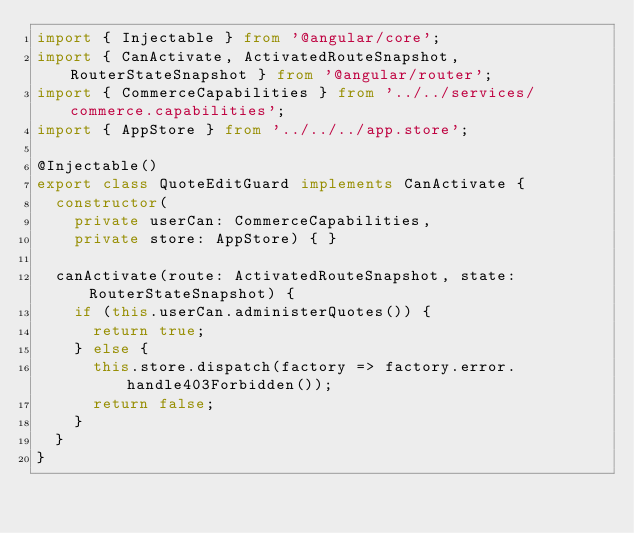Convert code to text. <code><loc_0><loc_0><loc_500><loc_500><_TypeScript_>import { Injectable } from '@angular/core';
import { CanActivate, ActivatedRouteSnapshot, RouterStateSnapshot } from '@angular/router';
import { CommerceCapabilities } from '../../services/commerce.capabilities';
import { AppStore } from '../../../app.store';

@Injectable()
export class QuoteEditGuard implements CanActivate {
  constructor(
    private userCan: CommerceCapabilities,
    private store: AppStore) { }

  canActivate(route: ActivatedRouteSnapshot, state: RouterStateSnapshot) {
    if (this.userCan.administerQuotes()) {
      return true;
    } else {
      this.store.dispatch(factory => factory.error.handle403Forbidden());
      return false;
    }
  }
}
</code> 